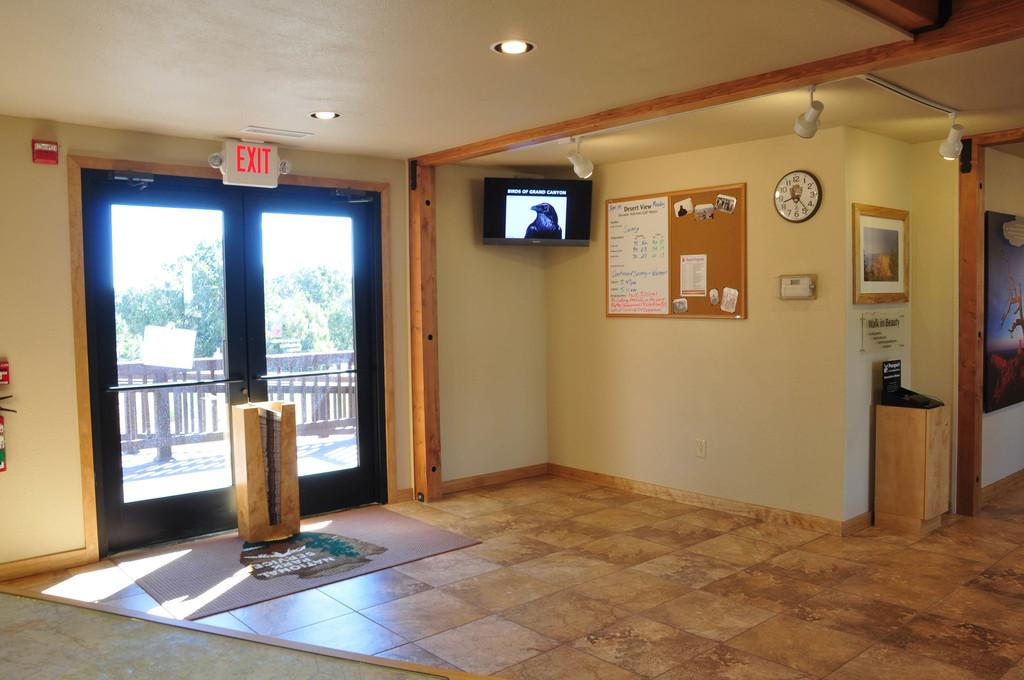What is one of the objects visible in the image? There is a door in the image. What is another object visible in the image? There is a television in the image. What is the third object visible in the image? There is a board in the image. What is the fourth object visible in the image? There is a clock in the image. What is the fifth object visible in the image? There is a photo frame in the image. What is the sixth object visible in the image? There are lights in the image. What can be seen behind the door in the image? There is a fence and trees visible behind the door. How does the board adjust to the quicksand in the image? There is no quicksand present in the image, and therefore no adjustment is necessary. 